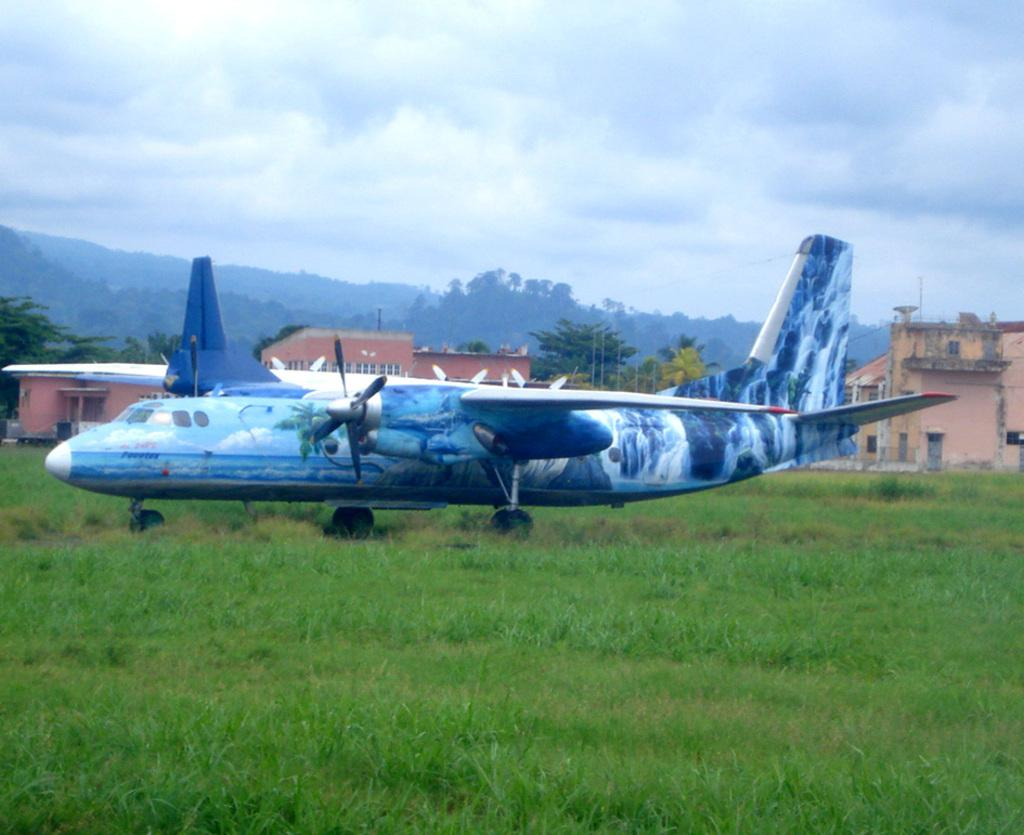What is the main subject of the picture? The main subject of the picture is an airplane. What can be seen at the bottom of the picture? There is grass at the bottom of the picture. What is visible in the background of the picture? There are buildings and trees in the background of the picture. What is visible at the top of the picture? The sky is visible at the top of the picture. What type of soup is being served by the fireman in the image? There is no fireman or soup present in the image; it features an airplane with grass, buildings, trees, and the sky visible. 